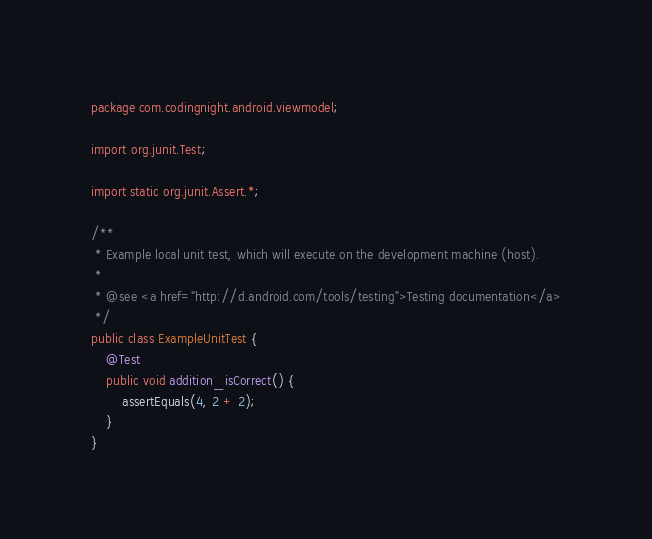Convert code to text. <code><loc_0><loc_0><loc_500><loc_500><_Java_>package com.codingnight.android.viewmodel;

import org.junit.Test;

import static org.junit.Assert.*;

/**
 * Example local unit test, which will execute on the development machine (host).
 *
 * @see <a href="http://d.android.com/tools/testing">Testing documentation</a>
 */
public class ExampleUnitTest {
    @Test
    public void addition_isCorrect() {
        assertEquals(4, 2 + 2);
    }
}</code> 